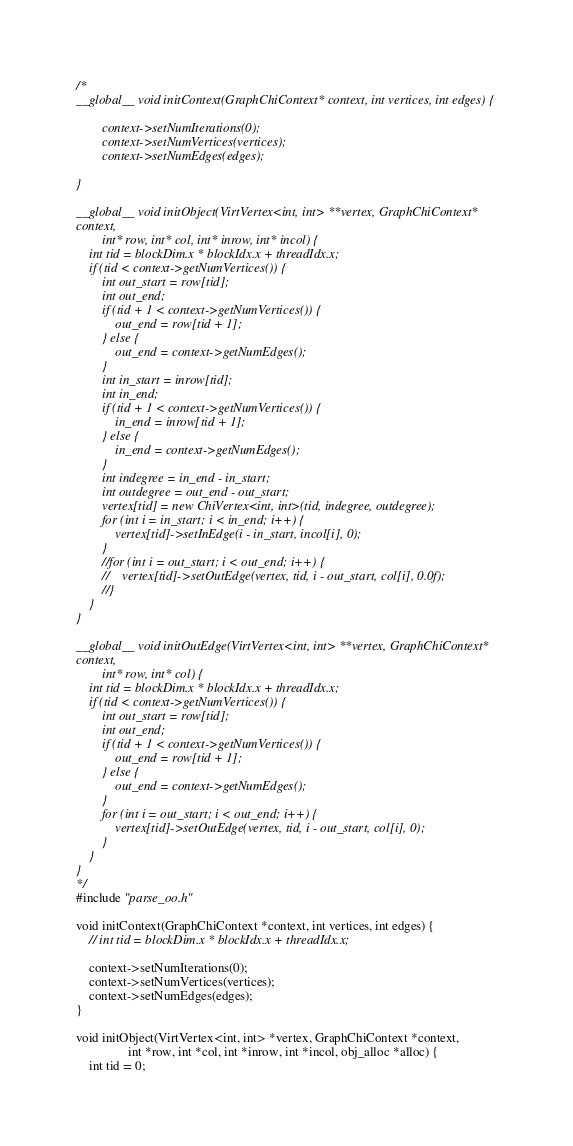<code> <loc_0><loc_0><loc_500><loc_500><_Cuda_>/*
__global__ void initContext(GraphChiContext* context, int vertices, int edges) {

        context->setNumIterations(0);
        context->setNumVertices(vertices);
        context->setNumEdges(edges);

}

__global__ void initObject(VirtVertex<int, int> **vertex, GraphChiContext*
context,
        int* row, int* col, int* inrow, int* incol) {
    int tid = blockDim.x * blockIdx.x + threadIdx.x;
    if (tid < context->getNumVertices()) {
        int out_start = row[tid];
        int out_end;
        if (tid + 1 < context->getNumVertices()) {
            out_end = row[tid + 1];
        } else {
            out_end = context->getNumEdges();
        }
        int in_start = inrow[tid];
        int in_end;
        if (tid + 1 < context->getNumVertices()) {
            in_end = inrow[tid + 1];
        } else {
            in_end = context->getNumEdges();
        }
        int indegree = in_end - in_start;
        int outdegree = out_end - out_start;
        vertex[tid] = new ChiVertex<int, int>(tid, indegree, outdegree);
        for (int i = in_start; i < in_end; i++) {
            vertex[tid]->setInEdge(i - in_start, incol[i], 0);
        }
        //for (int i = out_start; i < out_end; i++) {
        //    vertex[tid]->setOutEdge(vertex, tid, i - out_start, col[i], 0.0f);
        //}
    }
}

__global__ void initOutEdge(VirtVertex<int, int> **vertex, GraphChiContext*
context,
        int* row, int* col) {
    int tid = blockDim.x * blockIdx.x + threadIdx.x;
    if (tid < context->getNumVertices()) {
        int out_start = row[tid];
        int out_end;
        if (tid + 1 < context->getNumVertices()) {
            out_end = row[tid + 1];
        } else {
            out_end = context->getNumEdges();
        }
        for (int i = out_start; i < out_end; i++) {
            vertex[tid]->setOutEdge(vertex, tid, i - out_start, col[i], 0);
        }
    }
}
*/
#include "parse_oo.h"

void initContext(GraphChiContext *context, int vertices, int edges) {
    // int tid = blockDim.x * blockIdx.x + threadIdx.x;

    context->setNumIterations(0);
    context->setNumVertices(vertices);
    context->setNumEdges(edges);
}

void initObject(VirtVertex<int, int> *vertex, GraphChiContext *context,
                int *row, int *col, int *inrow, int *incol, obj_alloc *alloc) {
    int tid = 0;
</code> 